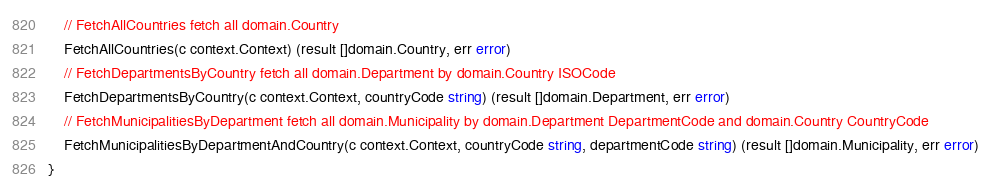<code> <loc_0><loc_0><loc_500><loc_500><_Go_>	// FetchAllCountries fetch all domain.Country
	FetchAllCountries(c context.Context) (result []domain.Country, err error)
	// FetchDepartmentsByCountry fetch all domain.Department by domain.Country ISOCode
	FetchDepartmentsByCountry(c context.Context, countryCode string) (result []domain.Department, err error)
	// FetchMunicipalitiesByDepartment fetch all domain.Municipality by domain.Department DepartmentCode and domain.Country CountryCode
	FetchMunicipalitiesByDepartmentAndCountry(c context.Context, countryCode string, departmentCode string) (result []domain.Municipality, err error)
}
</code> 